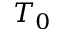Convert formula to latex. <formula><loc_0><loc_0><loc_500><loc_500>T _ { 0 }</formula> 